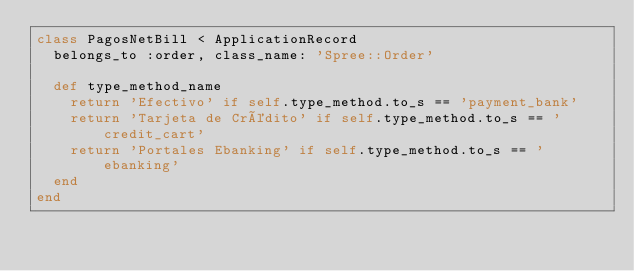<code> <loc_0><loc_0><loc_500><loc_500><_Ruby_>class PagosNetBill < ApplicationRecord
  belongs_to :order, class_name: 'Spree::Order'

  def type_method_name
    return 'Efectivo' if self.type_method.to_s == 'payment_bank'
    return 'Tarjeta de Crédito' if self.type_method.to_s == 'credit_cart'
    return 'Portales Ebanking' if self.type_method.to_s == 'ebanking'
  end
end
</code> 